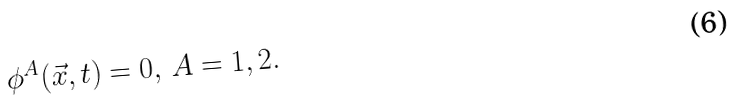Convert formula to latex. <formula><loc_0><loc_0><loc_500><loc_500>\phi ^ { A } ( \vec { x } , t ) = 0 , \, A = 1 , 2 .</formula> 